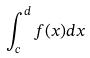<formula> <loc_0><loc_0><loc_500><loc_500>\int _ { c } ^ { d } f ( x ) d x</formula> 